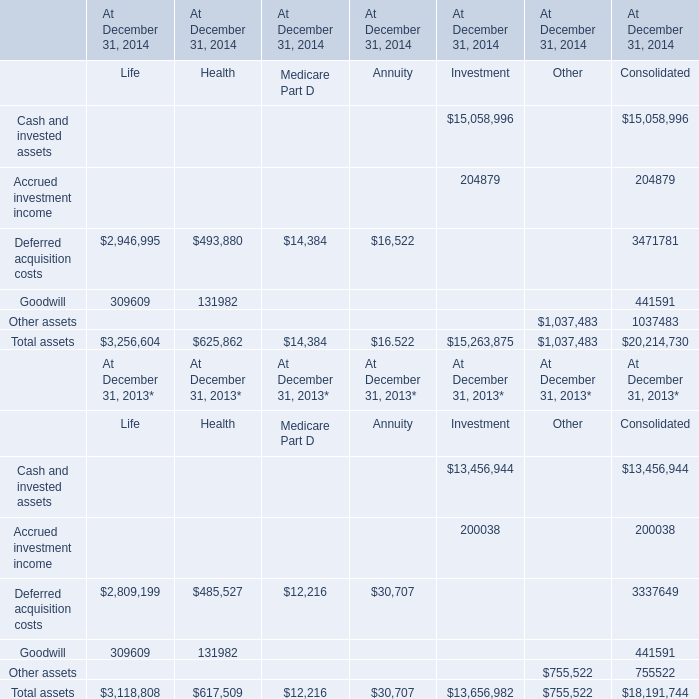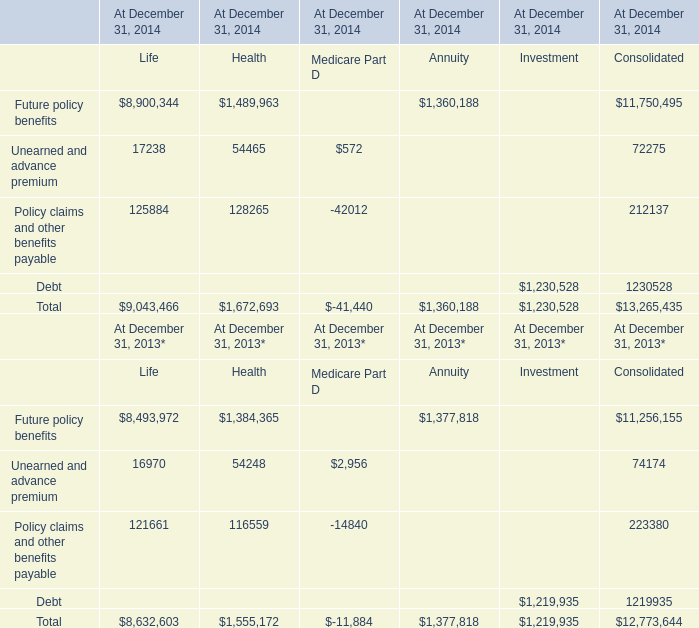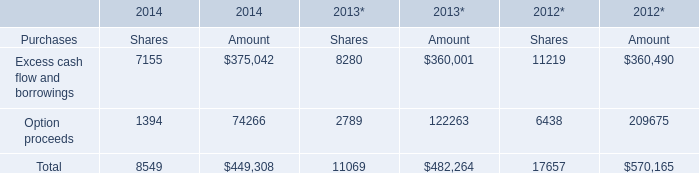the lessor is entitled to additional rent as defined by the lease agreement for what percentage of the original agreement? 
Computations: (140 / 49)
Answer: 2.85714. 